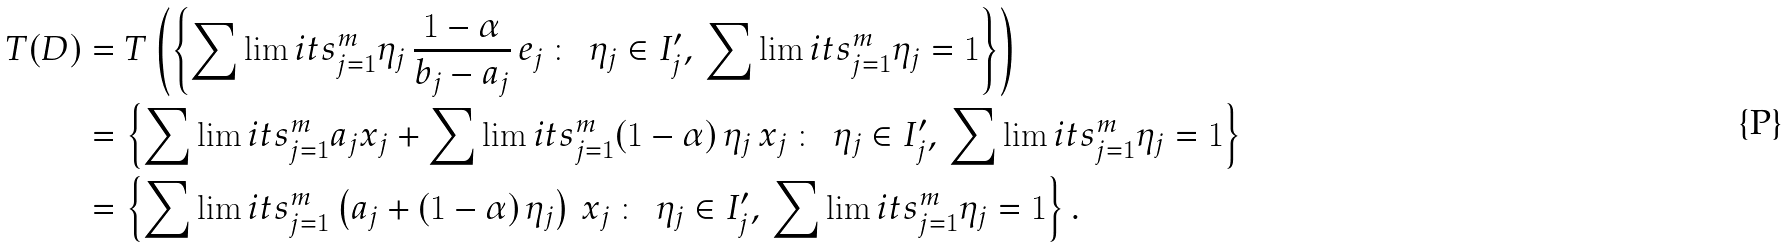Convert formula to latex. <formula><loc_0><loc_0><loc_500><loc_500>T ( D ) & = T \left ( \left \{ \sum \lim i t s _ { j = 1 } ^ { m } \eta _ { j } \, \frac { 1 - \alpha } { b _ { j } - a _ { j } } \, e _ { j } \, \colon \, \ \eta _ { j } \in I _ { j } ^ { \prime } , \, \sum \lim i t s _ { j = 1 } ^ { m } \eta _ { j } = 1 \right \} \right ) \\ & = \left \{ \sum \lim i t s _ { j = 1 } ^ { m } a _ { j } x _ { j } + \sum \lim i t s _ { j = 1 } ^ { m } ( 1 - \alpha ) \, \eta _ { j } \, x _ { j } \, \colon \, \ \eta _ { j } \in I _ { j } ^ { \prime } , \, \sum \lim i t s _ { j = 1 } ^ { m } \eta _ { j } = 1 \right \} \\ & = \left \{ \sum \lim i t s _ { j = 1 } ^ { m } \left ( a _ { j } + ( 1 - \alpha ) \, \eta _ { j } \right ) \, x _ { j } \, \colon \, \ \eta _ { j } \in I _ { j } ^ { \prime } , \, \sum \lim i t s _ { j = 1 } ^ { m } \eta _ { j } = 1 \right \} .</formula> 